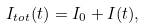<formula> <loc_0><loc_0><loc_500><loc_500>I _ { t o t } ( t ) = I _ { 0 } + I ( t ) ,</formula> 